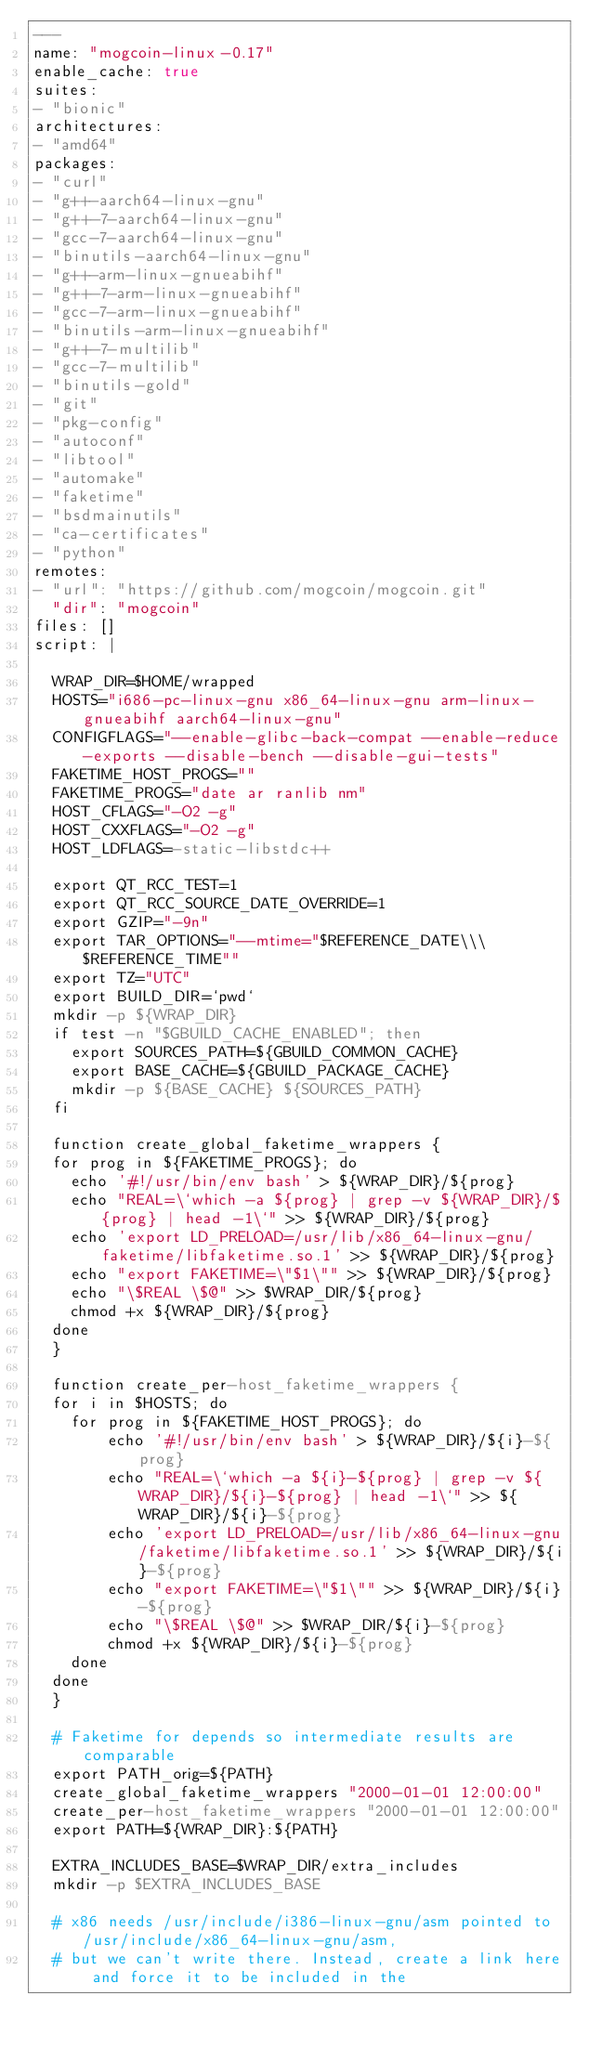<code> <loc_0><loc_0><loc_500><loc_500><_YAML_>---
name: "mogcoin-linux-0.17"
enable_cache: true
suites:
- "bionic"
architectures:
- "amd64"
packages:
- "curl"
- "g++-aarch64-linux-gnu"
- "g++-7-aarch64-linux-gnu"
- "gcc-7-aarch64-linux-gnu"
- "binutils-aarch64-linux-gnu"
- "g++-arm-linux-gnueabihf"
- "g++-7-arm-linux-gnueabihf"
- "gcc-7-arm-linux-gnueabihf"
- "binutils-arm-linux-gnueabihf"
- "g++-7-multilib"
- "gcc-7-multilib"
- "binutils-gold"
- "git"
- "pkg-config"
- "autoconf"
- "libtool"
- "automake"
- "faketime"
- "bsdmainutils"
- "ca-certificates"
- "python"
remotes:
- "url": "https://github.com/mogcoin/mogcoin.git"
  "dir": "mogcoin"
files: []
script: |

  WRAP_DIR=$HOME/wrapped
  HOSTS="i686-pc-linux-gnu x86_64-linux-gnu arm-linux-gnueabihf aarch64-linux-gnu"
  CONFIGFLAGS="--enable-glibc-back-compat --enable-reduce-exports --disable-bench --disable-gui-tests"
  FAKETIME_HOST_PROGS=""
  FAKETIME_PROGS="date ar ranlib nm"
  HOST_CFLAGS="-O2 -g"
  HOST_CXXFLAGS="-O2 -g"
  HOST_LDFLAGS=-static-libstdc++

  export QT_RCC_TEST=1
  export QT_RCC_SOURCE_DATE_OVERRIDE=1
  export GZIP="-9n"
  export TAR_OPTIONS="--mtime="$REFERENCE_DATE\\\ $REFERENCE_TIME""
  export TZ="UTC"
  export BUILD_DIR=`pwd`
  mkdir -p ${WRAP_DIR}
  if test -n "$GBUILD_CACHE_ENABLED"; then
    export SOURCES_PATH=${GBUILD_COMMON_CACHE}
    export BASE_CACHE=${GBUILD_PACKAGE_CACHE}
    mkdir -p ${BASE_CACHE} ${SOURCES_PATH}
  fi

  function create_global_faketime_wrappers {
  for prog in ${FAKETIME_PROGS}; do
    echo '#!/usr/bin/env bash' > ${WRAP_DIR}/${prog}
    echo "REAL=\`which -a ${prog} | grep -v ${WRAP_DIR}/${prog} | head -1\`" >> ${WRAP_DIR}/${prog}
    echo 'export LD_PRELOAD=/usr/lib/x86_64-linux-gnu/faketime/libfaketime.so.1' >> ${WRAP_DIR}/${prog}
    echo "export FAKETIME=\"$1\"" >> ${WRAP_DIR}/${prog}
    echo "\$REAL \$@" >> $WRAP_DIR/${prog}
    chmod +x ${WRAP_DIR}/${prog}
  done
  }

  function create_per-host_faketime_wrappers {
  for i in $HOSTS; do
    for prog in ${FAKETIME_HOST_PROGS}; do
        echo '#!/usr/bin/env bash' > ${WRAP_DIR}/${i}-${prog}
        echo "REAL=\`which -a ${i}-${prog} | grep -v ${WRAP_DIR}/${i}-${prog} | head -1\`" >> ${WRAP_DIR}/${i}-${prog}
        echo 'export LD_PRELOAD=/usr/lib/x86_64-linux-gnu/faketime/libfaketime.so.1' >> ${WRAP_DIR}/${i}-${prog}
        echo "export FAKETIME=\"$1\"" >> ${WRAP_DIR}/${i}-${prog}
        echo "\$REAL \$@" >> $WRAP_DIR/${i}-${prog}
        chmod +x ${WRAP_DIR}/${i}-${prog}
    done
  done
  }

  # Faketime for depends so intermediate results are comparable
  export PATH_orig=${PATH}
  create_global_faketime_wrappers "2000-01-01 12:00:00"
  create_per-host_faketime_wrappers "2000-01-01 12:00:00"
  export PATH=${WRAP_DIR}:${PATH}

  EXTRA_INCLUDES_BASE=$WRAP_DIR/extra_includes
  mkdir -p $EXTRA_INCLUDES_BASE

  # x86 needs /usr/include/i386-linux-gnu/asm pointed to /usr/include/x86_64-linux-gnu/asm,
  # but we can't write there. Instead, create a link here and force it to be included in the</code> 